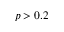Convert formula to latex. <formula><loc_0><loc_0><loc_500><loc_500>p > 0 . 2</formula> 